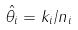<formula> <loc_0><loc_0><loc_500><loc_500>\hat { \theta _ { i } } = k _ { i } / n _ { i }</formula> 